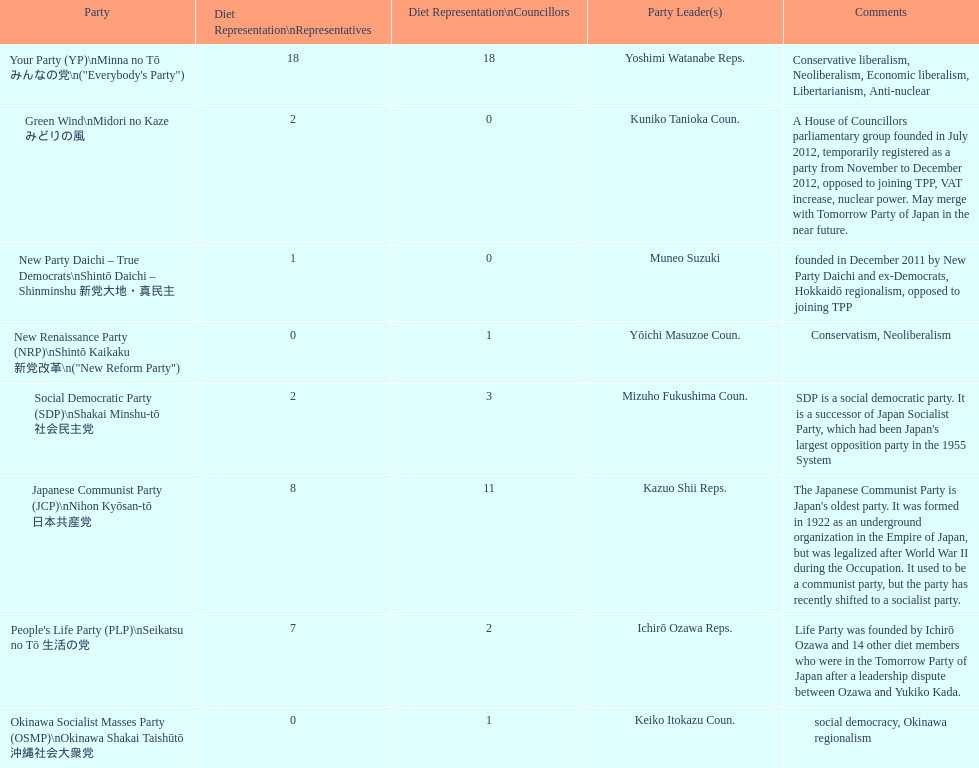According to this table, which party is japan's oldest political party? Japanese Communist Party (JCP) Nihon Kyōsan-tō 日本共産党. Give me the full table as a dictionary. {'header': ['Party', 'Diet Representation\\nRepresentatives', 'Diet Representation\\nCouncillors', 'Party Leader(s)', 'Comments'], 'rows': [['Your Party (YP)\\nMinna no Tō みんなの党\\n("Everybody\'s Party")', '18', '18', 'Yoshimi Watanabe Reps.', 'Conservative liberalism, Neoliberalism, Economic liberalism, Libertarianism, Anti-nuclear'], ['Green Wind\\nMidori no Kaze みどりの風', '2', '0', 'Kuniko Tanioka Coun.', 'A House of Councillors parliamentary group founded in July 2012, temporarily registered as a party from November to December 2012, opposed to joining TPP, VAT increase, nuclear power. May merge with Tomorrow Party of Japan in the near future.'], ['New Party Daichi – True Democrats\\nShintō Daichi – Shinminshu 新党大地・真民主', '1', '0', 'Muneo Suzuki', 'founded in December 2011 by New Party Daichi and ex-Democrats, Hokkaidō regionalism, opposed to joining TPP'], ['New Renaissance Party (NRP)\\nShintō Kaikaku 新党改革\\n("New Reform Party")', '0', '1', 'Yōichi Masuzoe Coun.', 'Conservatism, Neoliberalism'], ['Social Democratic Party (SDP)\\nShakai Minshu-tō 社会民主党', '2', '3', 'Mizuho Fukushima Coun.', "SDP is a social democratic party. It is a successor of Japan Socialist Party, which had been Japan's largest opposition party in the 1955 System"], ['Japanese Communist Party (JCP)\\nNihon Kyōsan-tō 日本共産党', '8', '11', 'Kazuo Shii Reps.', "The Japanese Communist Party is Japan's oldest party. It was formed in 1922 as an underground organization in the Empire of Japan, but was legalized after World War II during the Occupation. It used to be a communist party, but the party has recently shifted to a socialist party."], ["People's Life Party (PLP)\\nSeikatsu no Tō 生活の党", '7', '2', 'Ichirō Ozawa Reps.', 'Life Party was founded by Ichirō Ozawa and 14 other diet members who were in the Tomorrow Party of Japan after a leadership dispute between Ozawa and Yukiko Kada.'], ['Okinawa Socialist Masses Party (OSMP)\\nOkinawa Shakai Taishūtō 沖縄社会大衆党', '0', '1', 'Keiko Itokazu Coun.', 'social democracy, Okinawa regionalism']]} 